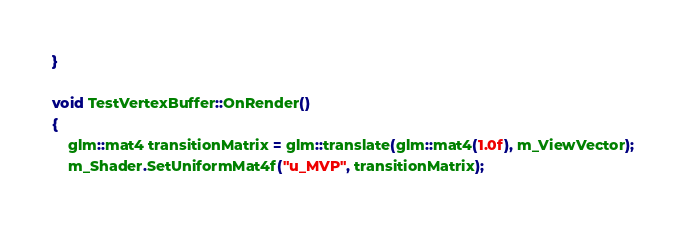Convert code to text. <code><loc_0><loc_0><loc_500><loc_500><_C++_>}

void TestVertexBuffer::OnRender()
{
	glm::mat4 transitionMatrix = glm::translate(glm::mat4(1.0f), m_ViewVector);
	m_Shader.SetUniformMat4f("u_MVP", transitionMatrix);</code> 